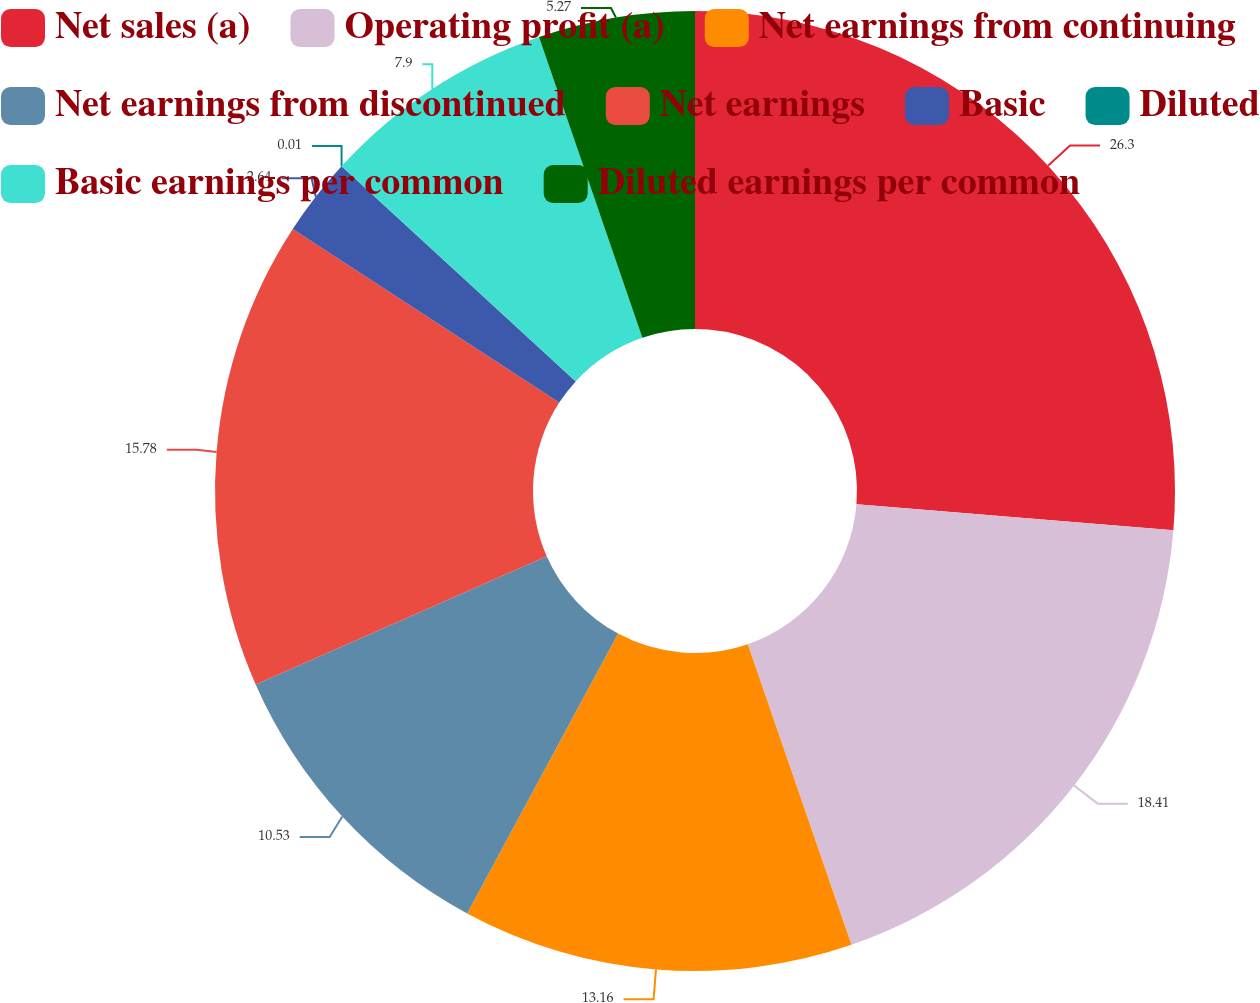Convert chart. <chart><loc_0><loc_0><loc_500><loc_500><pie_chart><fcel>Net sales (a)<fcel>Operating profit (a)<fcel>Net earnings from continuing<fcel>Net earnings from discontinued<fcel>Net earnings<fcel>Basic<fcel>Diluted<fcel>Basic earnings per common<fcel>Diluted earnings per common<nl><fcel>26.31%<fcel>18.42%<fcel>13.16%<fcel>10.53%<fcel>15.79%<fcel>2.64%<fcel>0.01%<fcel>7.9%<fcel>5.27%<nl></chart> 